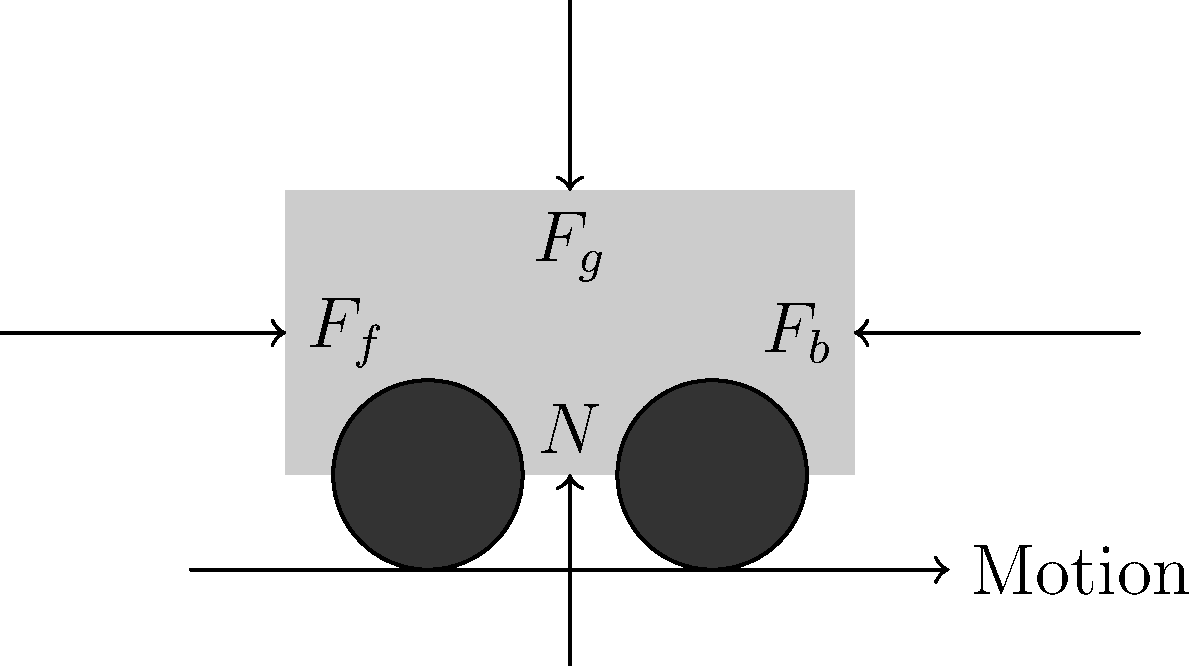During an emergency braking situation, a vehicle experiences several forces. In the force diagram provided, identify the force that is primarily responsible for decelerating the vehicle and explain its relationship to the other forces acting on the vehicle. To understand the forces acting on a vehicle during emergency braking, let's analyze each force in the diagram:

1. $F_g$: Gravitational force (weight of the vehicle)
   - Acts downward
   - Constant throughout the braking process

2. $N$: Normal force
   - Reaction force from the road surface
   - Balances the gravitational force on a level surface

3. $F_b$: Braking force
   - Applied by the brake system
   - Acts in the opposite direction of motion

4. $F_f$: Friction force
   - Acts between the tires and the road surface
   - Opposes the direction of motion

The primary force responsible for decelerating the vehicle is the friction force ($F_f$). This force is generated as a result of the braking force ($F_b$) applied by the brake system. The relationship between these forces is as follows:

1. When the brakes are applied, they create a torque on the wheels, causing them to slow down or stop rotating.
2. This action increases the friction between the tires and the road surface.
3. The friction force ($F_f$) is what actually slows down the vehicle, as it acts directly between the vehicle and the road.
4. The magnitude of $F_f$ is limited by the product of the normal force ($N$) and the coefficient of friction between the tires and the road.
5. The braking force ($F_b$) indirectly contributes to deceleration by creating the conditions for increased friction.

In summary, while the braking force initiates the process, it is the friction force that directly opposes the vehicle's motion and causes it to decelerate.
Answer: Friction force ($F_f$) 